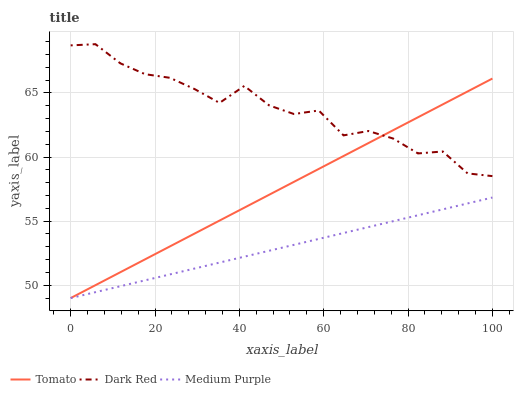Does Medium Purple have the minimum area under the curve?
Answer yes or no. Yes. Does Dark Red have the maximum area under the curve?
Answer yes or no. Yes. Does Dark Red have the minimum area under the curve?
Answer yes or no. No. Does Medium Purple have the maximum area under the curve?
Answer yes or no. No. Is Medium Purple the smoothest?
Answer yes or no. Yes. Is Dark Red the roughest?
Answer yes or no. Yes. Is Dark Red the smoothest?
Answer yes or no. No. Is Medium Purple the roughest?
Answer yes or no. No. Does Tomato have the lowest value?
Answer yes or no. Yes. Does Dark Red have the lowest value?
Answer yes or no. No. Does Dark Red have the highest value?
Answer yes or no. Yes. Does Medium Purple have the highest value?
Answer yes or no. No. Is Medium Purple less than Dark Red?
Answer yes or no. Yes. Is Dark Red greater than Medium Purple?
Answer yes or no. Yes. Does Tomato intersect Medium Purple?
Answer yes or no. Yes. Is Tomato less than Medium Purple?
Answer yes or no. No. Is Tomato greater than Medium Purple?
Answer yes or no. No. Does Medium Purple intersect Dark Red?
Answer yes or no. No. 